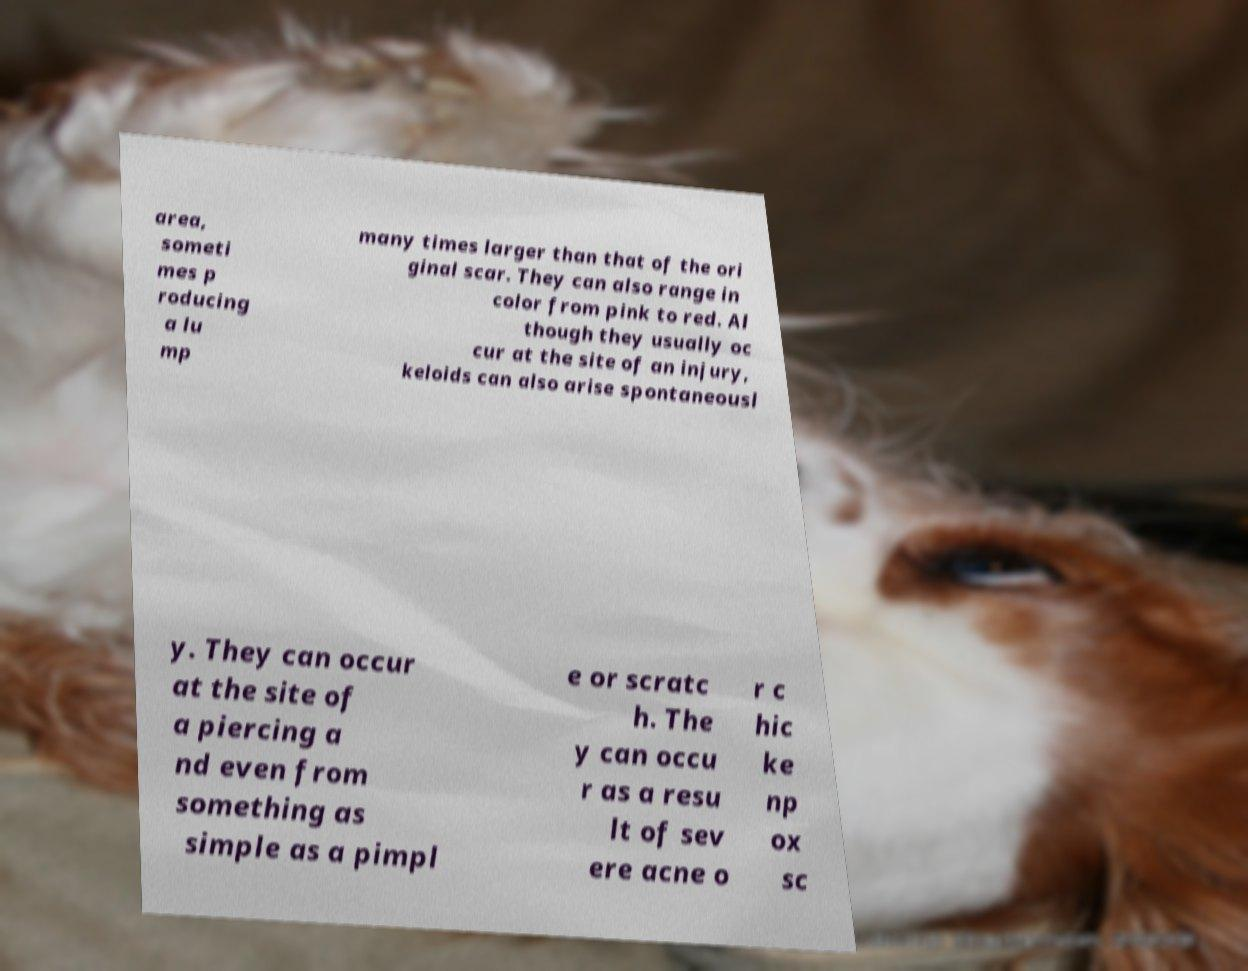Could you extract and type out the text from this image? area, someti mes p roducing a lu mp many times larger than that of the ori ginal scar. They can also range in color from pink to red. Al though they usually oc cur at the site of an injury, keloids can also arise spontaneousl y. They can occur at the site of a piercing a nd even from something as simple as a pimpl e or scratc h. The y can occu r as a resu lt of sev ere acne o r c hic ke np ox sc 